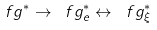Convert formula to latex. <formula><loc_0><loc_0><loc_500><loc_500>\ f g ^ { * } \to \ f g ^ { * } _ { e } \leftrightarrow \ f g ^ { * } _ { \xi }</formula> 